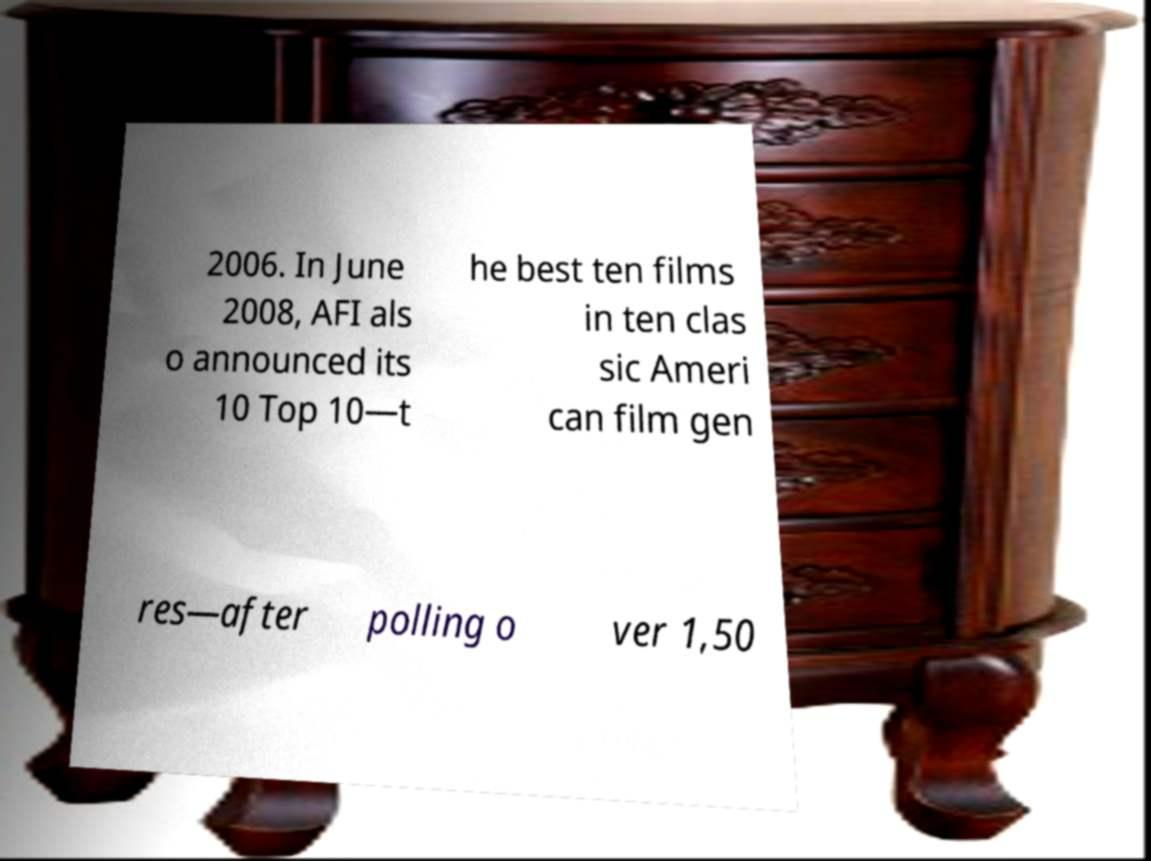I need the written content from this picture converted into text. Can you do that? 2006. In June 2008, AFI als o announced its 10 Top 10—t he best ten films in ten clas sic Ameri can film gen res—after polling o ver 1,50 